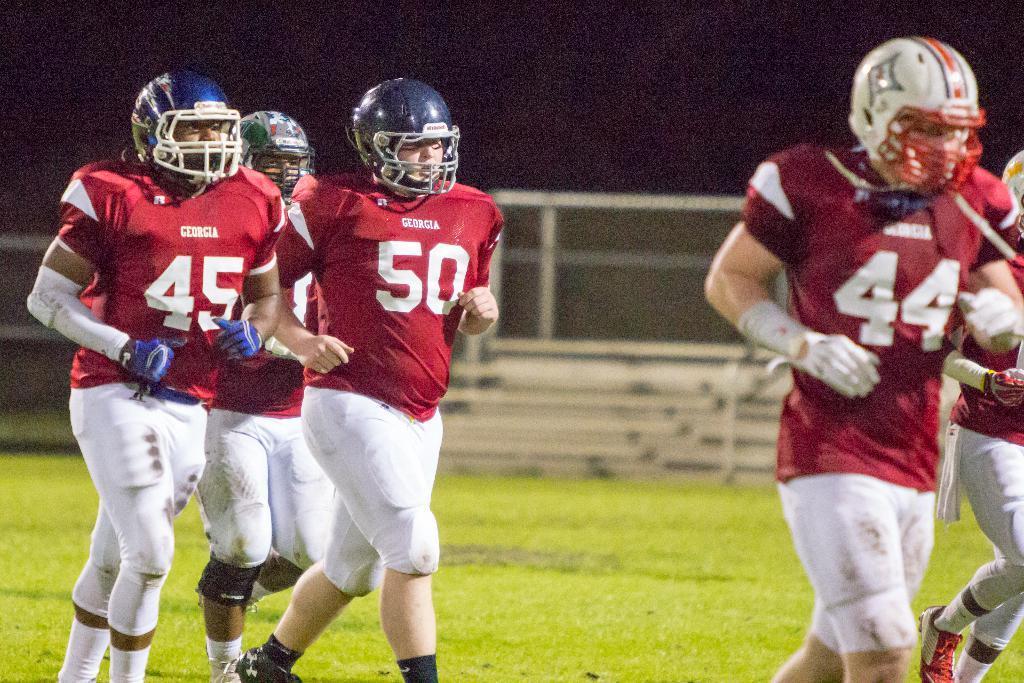In one or two sentences, can you explain what this image depicts? In the foreground we can see men running on a grass court. In the background there are staircase, fencing and grass. At the top it is dark. 